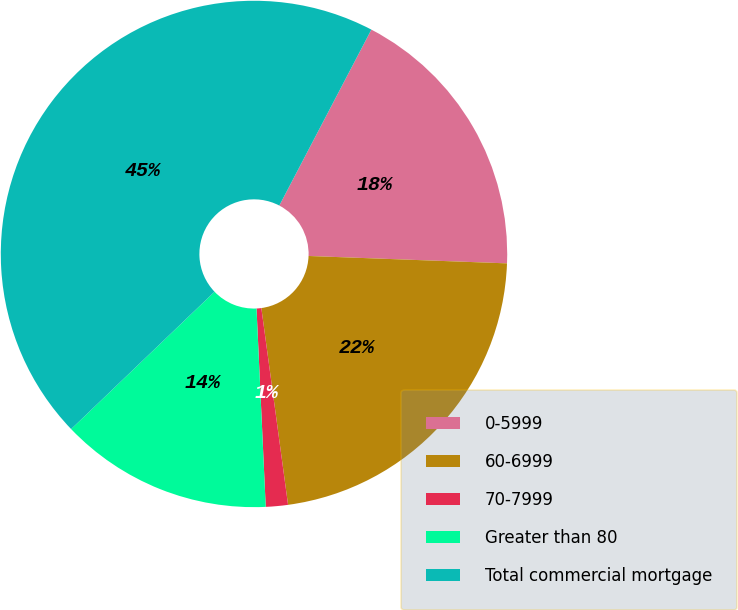Convert chart to OTSL. <chart><loc_0><loc_0><loc_500><loc_500><pie_chart><fcel>0-5999<fcel>60-6999<fcel>70-7999<fcel>Greater than 80<fcel>Total commercial mortgage<nl><fcel>17.92%<fcel>22.26%<fcel>1.41%<fcel>13.58%<fcel>44.83%<nl></chart> 